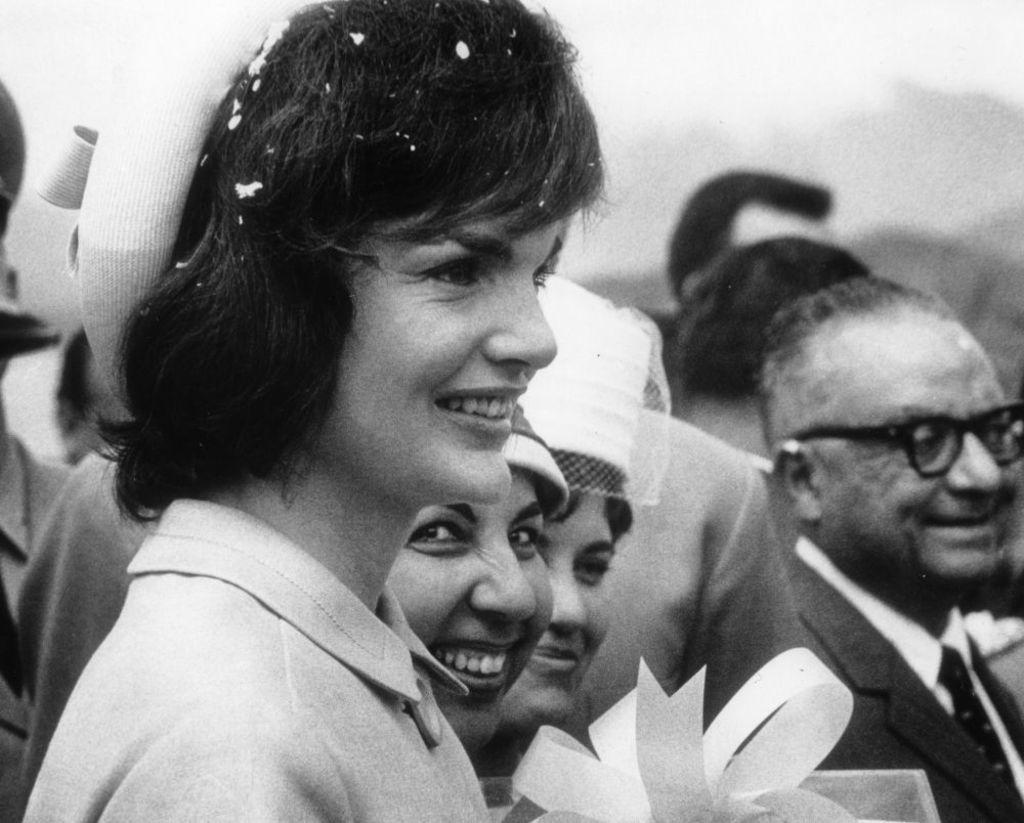Can you describe this image briefly? This is a black and white picture. Here we can see few persons and they are smiling. There is a blur background. 